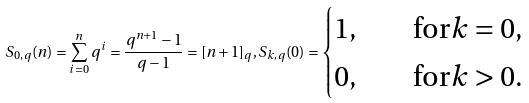Convert formula to latex. <formula><loc_0><loc_0><loc_500><loc_500>S _ { 0 , q } ( n ) = \sum _ { i = 0 } ^ { n } q ^ { i } = \frac { q ^ { n + 1 } - 1 } { q - 1 } = [ n + 1 ] _ { q } , S _ { k , q } ( 0 ) = \begin{cases} 1 , & \quad \text {for} k = 0 , \\ 0 , & \quad \text {for} k > 0 . \end{cases}</formula> 